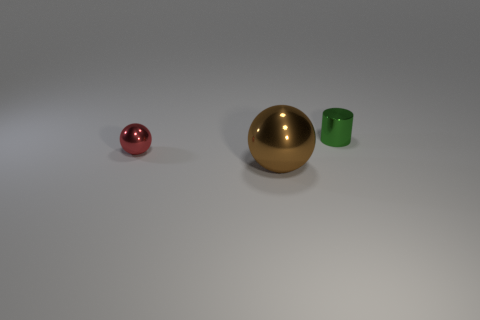What can you tell me about the lighting and shadows in the image? The lighting in the image seems uniform and diffused, casting soft shadows directly below the objects, which indicates an overhead light source. The lack of harsh shadows suggests the light is not highly directional, which often results from studio lighting or an overcast sky in an outdoor setting. 